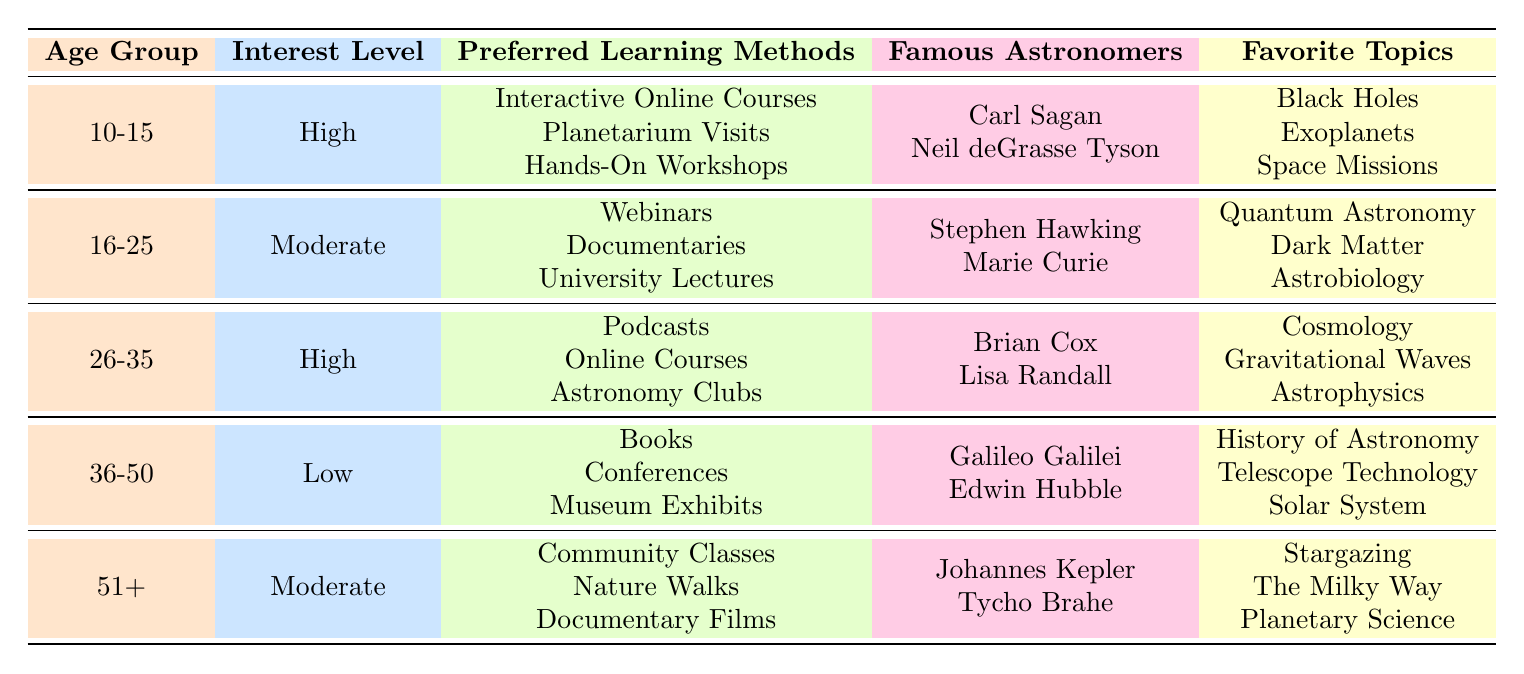What is the preferred learning method for the age group 10-15? The preferred learning methods for the age group 10-15 are listed in the table as Interactive Online Courses, Planetarium Visits, and Hands-On Workshops.
Answer: Interactive Online Courses, Planetarium Visits, Hands-On Workshops What is the interest level of individuals aged 36-50? According to the table, the interest level for individuals aged 36-50 is categorized as Low.
Answer: Low How many famous astronomers are listed for the age group 16-25? The table shows two famous astronomers associated with the age group 16-25: Stephen Hawking and Marie Curie.
Answer: 2 Which age group has the highest interest level? The age groups 10-15 and 26-35 both have a High interest level, according to the table. Upon closer examination, they share this interest level but differ in sample size and topics.
Answer: 10-15 and 26-35 What are the favorite topics for the age group 51+? For the age group 51+, the favorite topics are Stargazing, The Milky Way, and Planetary Science, as displayed in the table.
Answer: Stargazing, The Milky Way, Planetary Science What is the total sample size of respondents from the age groups with high interest levels? The sample sizes for the age groups with high interest (10-15 and 26-35) are 1200 and 1000, respectively. Adding them gives us a total of 2200 (1200 + 1000).
Answer: 2200 Is Astronomy Clubs a preferred learning method for anyone older than 35? Referring to the table, Astronomy Clubs is listed as a preferred learning method only for the age group 26-35, which is younger than 35. Therefore, the answer is No.
Answer: No Which famous astronomer is associated with the highest interest level age group? The age group 10-15 has a high interest level and lists Carl Sagan and Neil deGrasse Tyson as famous astronomers. Therefore, the answer refers to this group.
Answer: Carl Sagan, Neil deGrasse Tyson What is the difference in sample size between the age groups with high and low interest levels? The age groups with high interest (10-15 and 26-35) have a combined sample size of 2200 (1200 + 1000), while the age group with low interest (36-50) has a sample size of 800. The difference is 1400 (2200 - 800).
Answer: 1400 Which learning method is not preferred by the age group 51+? Looking at the table, the age group 51+ prefers Community Classes, Nature Walks, and Documentary Films. Thus, learning methods like Webinars, Podcasts, and Interactive Online Courses, which are favored by other groups, are not preferred by this age group.
Answer: Webinars, Podcasts, Interactive Online Courses 